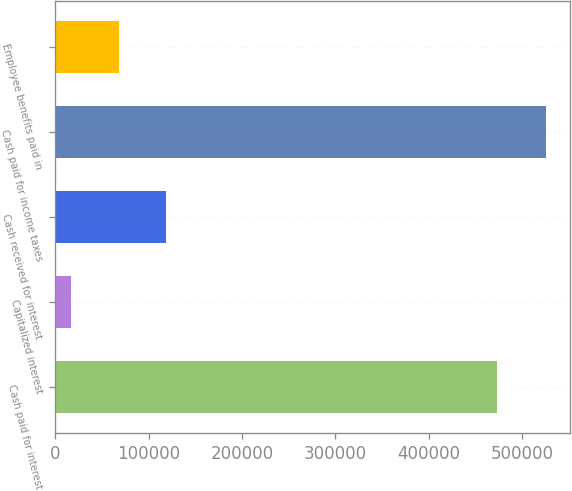<chart> <loc_0><loc_0><loc_500><loc_500><bar_chart><fcel>Cash paid for interest<fcel>Capitalized interest<fcel>Cash received for interest<fcel>Cash paid for income taxes<fcel>Employee benefits paid in<nl><fcel>472586<fcel>17139<fcel>118717<fcel>525028<fcel>67927.9<nl></chart> 